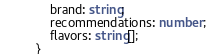Convert code to text. <code><loc_0><loc_0><loc_500><loc_500><_TypeScript_>    brand: string;
    recommendations: number;
    flavors: string[];
}
</code> 